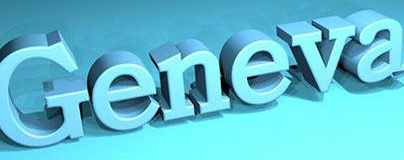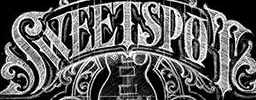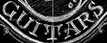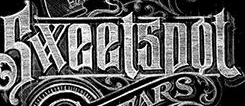Transcribe the words shown in these images in order, separated by a semicolon. Geneva; SWEETSPOT; GUITARS; Sweetspot 